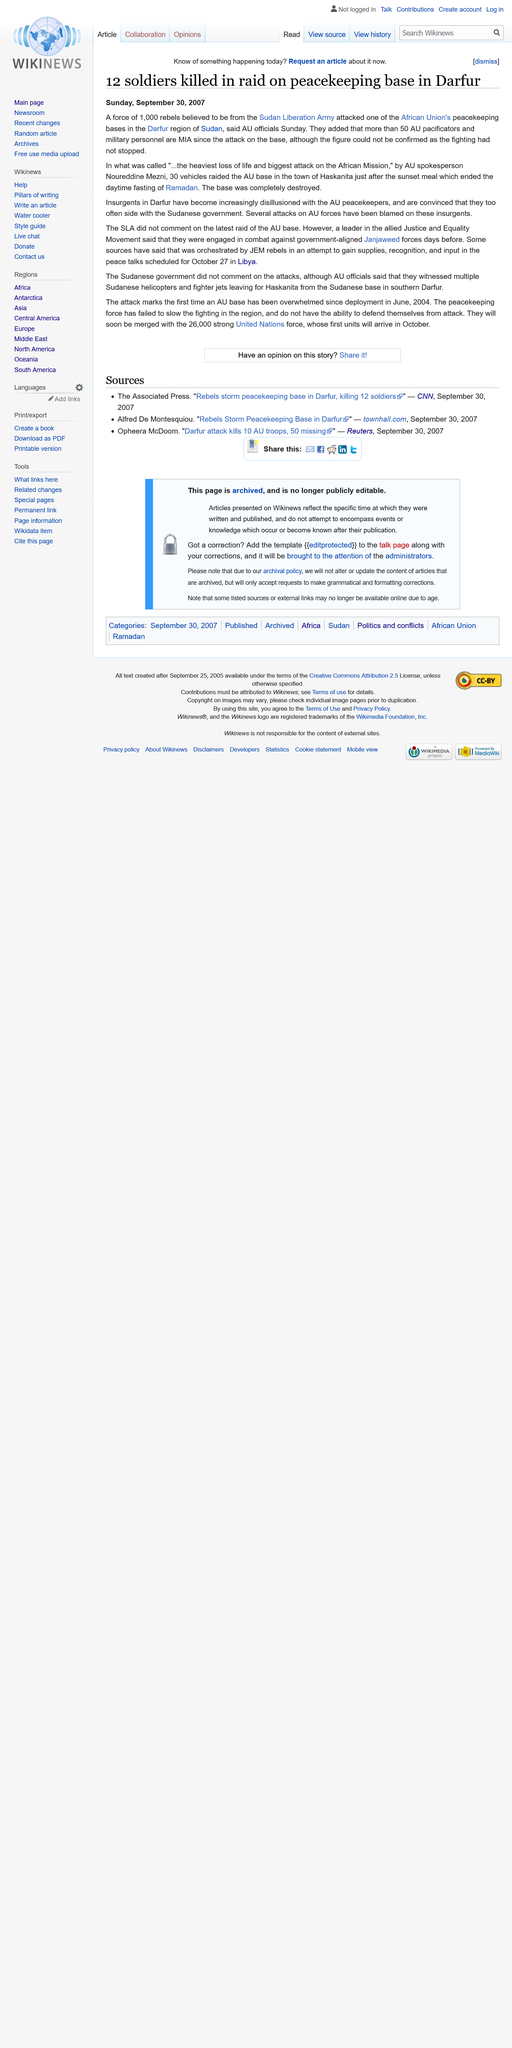Highlight a few significant elements in this photo. Thirty vehicles attacked the African Union's base. The Sudan Liberation Army is believed to be the home of the rebels. Since the attack on the AU pacificators and military personnel in the Pacific region, more than 50 individuals have gone missing, leaving their families and loved ones with a sense of uncertainty and grief. 